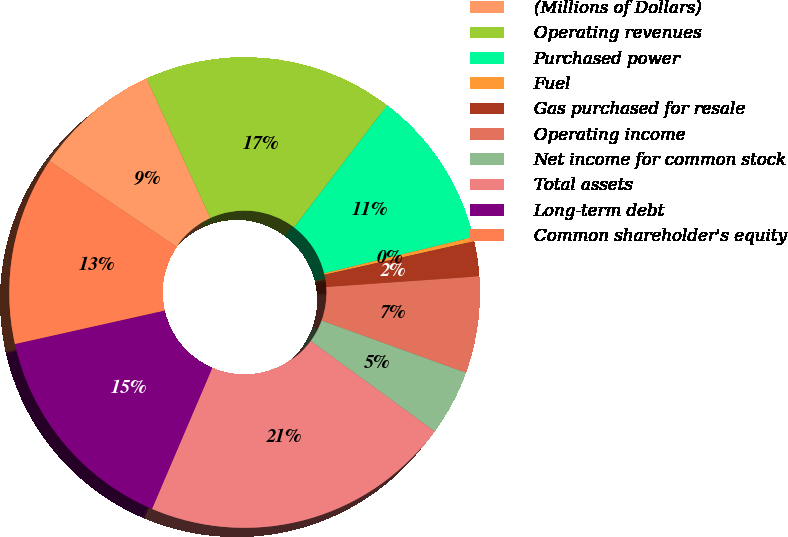Convert chart. <chart><loc_0><loc_0><loc_500><loc_500><pie_chart><fcel>(Millions of Dollars)<fcel>Operating revenues<fcel>Purchased power<fcel>Fuel<fcel>Gas purchased for resale<fcel>Operating income<fcel>Net income for common stock<fcel>Total assets<fcel>Long-term debt<fcel>Common shareholder's equity<nl><fcel>8.73%<fcel>17.17%<fcel>10.84%<fcel>0.29%<fcel>2.4%<fcel>6.62%<fcel>4.51%<fcel>21.39%<fcel>15.06%<fcel>12.95%<nl></chart> 